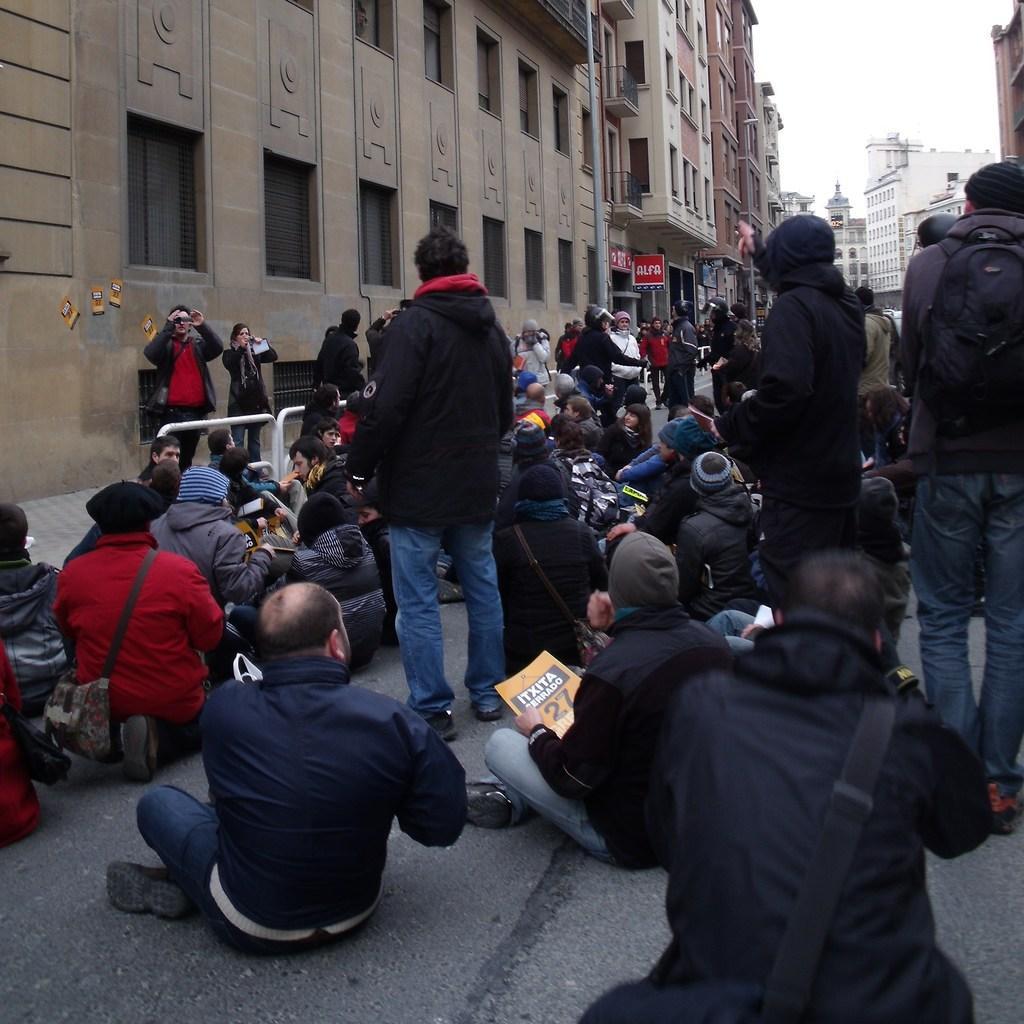Can you describe this image briefly? In this image we can see people are sitting on the road and there are few people standing on the road. In the background we can see buildings, boards, poles, and sky. 